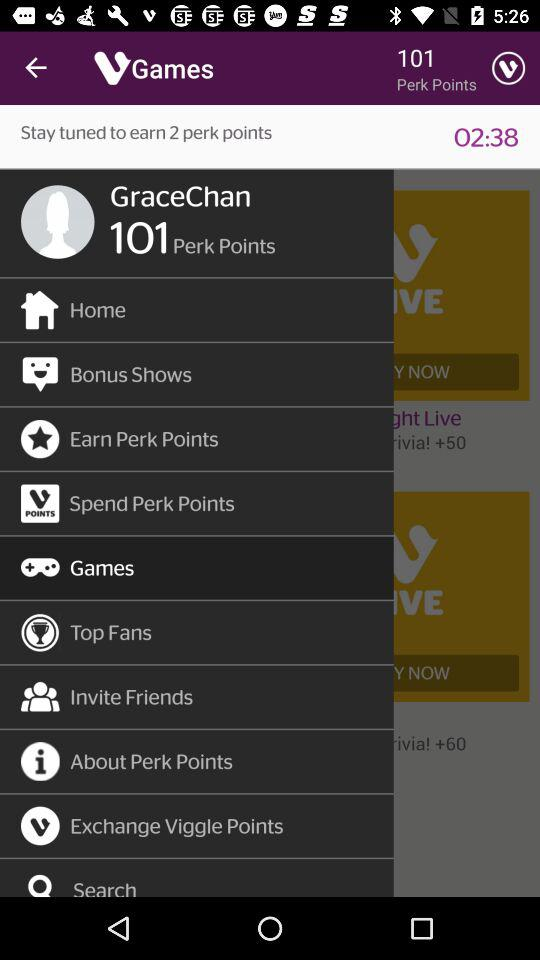What is the name of the application? The name of the application is "Viggle". 